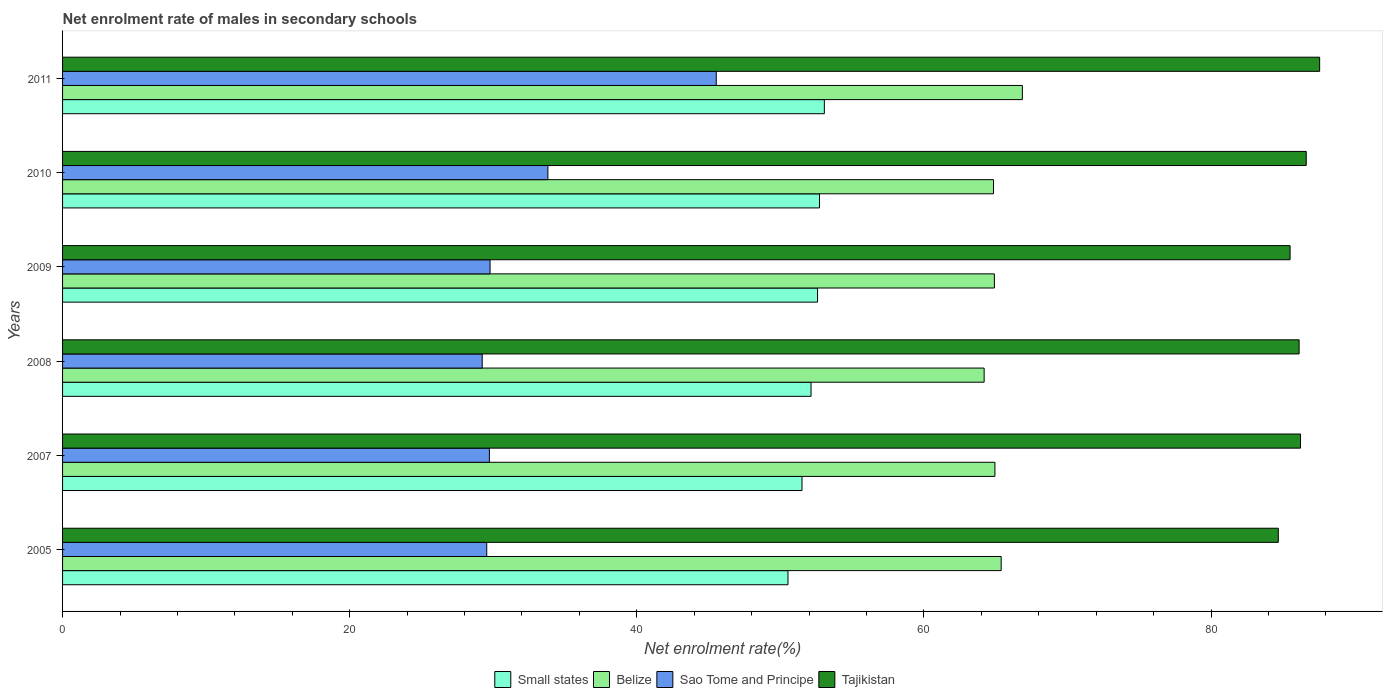How many different coloured bars are there?
Give a very brief answer. 4. How many groups of bars are there?
Your answer should be very brief. 6. Are the number of bars per tick equal to the number of legend labels?
Your response must be concise. Yes. How many bars are there on the 5th tick from the bottom?
Provide a succinct answer. 4. What is the net enrolment rate of males in secondary schools in Tajikistan in 2010?
Your answer should be compact. 86.63. Across all years, what is the maximum net enrolment rate of males in secondary schools in Sao Tome and Principe?
Give a very brief answer. 45.53. Across all years, what is the minimum net enrolment rate of males in secondary schools in Small states?
Give a very brief answer. 50.53. What is the total net enrolment rate of males in secondary schools in Sao Tome and Principe in the graph?
Provide a succinct answer. 197.62. What is the difference between the net enrolment rate of males in secondary schools in Sao Tome and Principe in 2008 and that in 2011?
Your response must be concise. -16.3. What is the difference between the net enrolment rate of males in secondary schools in Sao Tome and Principe in 2010 and the net enrolment rate of males in secondary schools in Belize in 2011?
Offer a very short reply. -33.05. What is the average net enrolment rate of males in secondary schools in Small states per year?
Make the answer very short. 52.09. In the year 2011, what is the difference between the net enrolment rate of males in secondary schools in Sao Tome and Principe and net enrolment rate of males in secondary schools in Tajikistan?
Keep it short and to the point. -42.03. What is the ratio of the net enrolment rate of males in secondary schools in Small states in 2010 to that in 2011?
Your answer should be compact. 0.99. Is the net enrolment rate of males in secondary schools in Tajikistan in 2007 less than that in 2011?
Make the answer very short. Yes. What is the difference between the highest and the second highest net enrolment rate of males in secondary schools in Small states?
Provide a succinct answer. 0.34. What is the difference between the highest and the lowest net enrolment rate of males in secondary schools in Small states?
Provide a succinct answer. 2.53. In how many years, is the net enrolment rate of males in secondary schools in Tajikistan greater than the average net enrolment rate of males in secondary schools in Tajikistan taken over all years?
Give a very brief answer. 4. Is the sum of the net enrolment rate of males in secondary schools in Sao Tome and Principe in 2008 and 2010 greater than the maximum net enrolment rate of males in secondary schools in Tajikistan across all years?
Make the answer very short. No. What does the 3rd bar from the top in 2005 represents?
Keep it short and to the point. Belize. What does the 2nd bar from the bottom in 2005 represents?
Provide a short and direct response. Belize. Are all the bars in the graph horizontal?
Offer a very short reply. Yes. How many years are there in the graph?
Offer a very short reply. 6. What is the difference between two consecutive major ticks on the X-axis?
Your answer should be very brief. 20. Does the graph contain grids?
Provide a short and direct response. No. Where does the legend appear in the graph?
Keep it short and to the point. Bottom center. What is the title of the graph?
Provide a succinct answer. Net enrolment rate of males in secondary schools. What is the label or title of the X-axis?
Your response must be concise. Net enrolment rate(%). What is the label or title of the Y-axis?
Your response must be concise. Years. What is the Net enrolment rate(%) of Small states in 2005?
Offer a terse response. 50.53. What is the Net enrolment rate(%) in Belize in 2005?
Give a very brief answer. 65.38. What is the Net enrolment rate(%) of Sao Tome and Principe in 2005?
Give a very brief answer. 29.54. What is the Net enrolment rate(%) in Tajikistan in 2005?
Keep it short and to the point. 84.68. What is the Net enrolment rate(%) in Small states in 2007?
Provide a short and direct response. 51.5. What is the Net enrolment rate(%) of Belize in 2007?
Ensure brevity in your answer.  64.94. What is the Net enrolment rate(%) of Sao Tome and Principe in 2007?
Your answer should be very brief. 29.73. What is the Net enrolment rate(%) in Tajikistan in 2007?
Your answer should be compact. 86.23. What is the Net enrolment rate(%) of Small states in 2008?
Provide a succinct answer. 52.13. What is the Net enrolment rate(%) of Belize in 2008?
Provide a succinct answer. 64.19. What is the Net enrolment rate(%) in Sao Tome and Principe in 2008?
Your answer should be compact. 29.23. What is the Net enrolment rate(%) in Tajikistan in 2008?
Provide a short and direct response. 86.13. What is the Net enrolment rate(%) in Small states in 2009?
Your response must be concise. 52.59. What is the Net enrolment rate(%) in Belize in 2009?
Your answer should be very brief. 64.9. What is the Net enrolment rate(%) in Sao Tome and Principe in 2009?
Offer a terse response. 29.78. What is the Net enrolment rate(%) of Tajikistan in 2009?
Offer a very short reply. 85.5. What is the Net enrolment rate(%) in Small states in 2010?
Your response must be concise. 52.72. What is the Net enrolment rate(%) of Belize in 2010?
Make the answer very short. 64.84. What is the Net enrolment rate(%) of Sao Tome and Principe in 2010?
Ensure brevity in your answer.  33.8. What is the Net enrolment rate(%) in Tajikistan in 2010?
Ensure brevity in your answer.  86.63. What is the Net enrolment rate(%) of Small states in 2011?
Ensure brevity in your answer.  53.06. What is the Net enrolment rate(%) of Belize in 2011?
Offer a terse response. 66.85. What is the Net enrolment rate(%) in Sao Tome and Principe in 2011?
Make the answer very short. 45.53. What is the Net enrolment rate(%) of Tajikistan in 2011?
Offer a terse response. 87.56. Across all years, what is the maximum Net enrolment rate(%) of Small states?
Offer a very short reply. 53.06. Across all years, what is the maximum Net enrolment rate(%) of Belize?
Your answer should be compact. 66.85. Across all years, what is the maximum Net enrolment rate(%) in Sao Tome and Principe?
Your answer should be very brief. 45.53. Across all years, what is the maximum Net enrolment rate(%) of Tajikistan?
Provide a short and direct response. 87.56. Across all years, what is the minimum Net enrolment rate(%) in Small states?
Offer a terse response. 50.53. Across all years, what is the minimum Net enrolment rate(%) in Belize?
Keep it short and to the point. 64.19. Across all years, what is the minimum Net enrolment rate(%) in Sao Tome and Principe?
Ensure brevity in your answer.  29.23. Across all years, what is the minimum Net enrolment rate(%) of Tajikistan?
Keep it short and to the point. 84.68. What is the total Net enrolment rate(%) in Small states in the graph?
Offer a terse response. 312.54. What is the total Net enrolment rate(%) of Belize in the graph?
Offer a very short reply. 391.11. What is the total Net enrolment rate(%) of Sao Tome and Principe in the graph?
Your answer should be compact. 197.62. What is the total Net enrolment rate(%) in Tajikistan in the graph?
Offer a very short reply. 516.72. What is the difference between the Net enrolment rate(%) in Small states in 2005 and that in 2007?
Your answer should be very brief. -0.98. What is the difference between the Net enrolment rate(%) in Belize in 2005 and that in 2007?
Your response must be concise. 0.44. What is the difference between the Net enrolment rate(%) in Sao Tome and Principe in 2005 and that in 2007?
Offer a very short reply. -0.18. What is the difference between the Net enrolment rate(%) in Tajikistan in 2005 and that in 2007?
Your response must be concise. -1.55. What is the difference between the Net enrolment rate(%) of Small states in 2005 and that in 2008?
Your response must be concise. -1.61. What is the difference between the Net enrolment rate(%) in Belize in 2005 and that in 2008?
Your answer should be compact. 1.19. What is the difference between the Net enrolment rate(%) of Sao Tome and Principe in 2005 and that in 2008?
Offer a terse response. 0.31. What is the difference between the Net enrolment rate(%) in Tajikistan in 2005 and that in 2008?
Provide a succinct answer. -1.45. What is the difference between the Net enrolment rate(%) of Small states in 2005 and that in 2009?
Your answer should be very brief. -2.06. What is the difference between the Net enrolment rate(%) in Belize in 2005 and that in 2009?
Offer a terse response. 0.47. What is the difference between the Net enrolment rate(%) in Sao Tome and Principe in 2005 and that in 2009?
Give a very brief answer. -0.23. What is the difference between the Net enrolment rate(%) in Tajikistan in 2005 and that in 2009?
Provide a short and direct response. -0.82. What is the difference between the Net enrolment rate(%) in Small states in 2005 and that in 2010?
Your answer should be compact. -2.2. What is the difference between the Net enrolment rate(%) of Belize in 2005 and that in 2010?
Ensure brevity in your answer.  0.54. What is the difference between the Net enrolment rate(%) in Sao Tome and Principe in 2005 and that in 2010?
Provide a short and direct response. -4.26. What is the difference between the Net enrolment rate(%) in Tajikistan in 2005 and that in 2010?
Your response must be concise. -1.95. What is the difference between the Net enrolment rate(%) in Small states in 2005 and that in 2011?
Keep it short and to the point. -2.53. What is the difference between the Net enrolment rate(%) of Belize in 2005 and that in 2011?
Ensure brevity in your answer.  -1.47. What is the difference between the Net enrolment rate(%) in Sao Tome and Principe in 2005 and that in 2011?
Provide a short and direct response. -15.99. What is the difference between the Net enrolment rate(%) of Tajikistan in 2005 and that in 2011?
Ensure brevity in your answer.  -2.88. What is the difference between the Net enrolment rate(%) of Small states in 2007 and that in 2008?
Your answer should be very brief. -0.63. What is the difference between the Net enrolment rate(%) in Belize in 2007 and that in 2008?
Offer a terse response. 0.75. What is the difference between the Net enrolment rate(%) of Sao Tome and Principe in 2007 and that in 2008?
Ensure brevity in your answer.  0.5. What is the difference between the Net enrolment rate(%) in Tajikistan in 2007 and that in 2008?
Provide a succinct answer. 0.1. What is the difference between the Net enrolment rate(%) of Small states in 2007 and that in 2009?
Provide a succinct answer. -1.08. What is the difference between the Net enrolment rate(%) of Belize in 2007 and that in 2009?
Your answer should be very brief. 0.04. What is the difference between the Net enrolment rate(%) of Sao Tome and Principe in 2007 and that in 2009?
Offer a terse response. -0.05. What is the difference between the Net enrolment rate(%) in Tajikistan in 2007 and that in 2009?
Give a very brief answer. 0.73. What is the difference between the Net enrolment rate(%) in Small states in 2007 and that in 2010?
Your answer should be very brief. -1.22. What is the difference between the Net enrolment rate(%) in Belize in 2007 and that in 2010?
Ensure brevity in your answer.  0.1. What is the difference between the Net enrolment rate(%) of Sao Tome and Principe in 2007 and that in 2010?
Your answer should be very brief. -4.08. What is the difference between the Net enrolment rate(%) of Tajikistan in 2007 and that in 2010?
Your answer should be compact. -0.4. What is the difference between the Net enrolment rate(%) of Small states in 2007 and that in 2011?
Provide a succinct answer. -1.56. What is the difference between the Net enrolment rate(%) of Belize in 2007 and that in 2011?
Your response must be concise. -1.91. What is the difference between the Net enrolment rate(%) of Sao Tome and Principe in 2007 and that in 2011?
Give a very brief answer. -15.8. What is the difference between the Net enrolment rate(%) in Tajikistan in 2007 and that in 2011?
Your answer should be compact. -1.33. What is the difference between the Net enrolment rate(%) in Small states in 2008 and that in 2009?
Make the answer very short. -0.45. What is the difference between the Net enrolment rate(%) in Belize in 2008 and that in 2009?
Give a very brief answer. -0.71. What is the difference between the Net enrolment rate(%) in Sao Tome and Principe in 2008 and that in 2009?
Provide a short and direct response. -0.55. What is the difference between the Net enrolment rate(%) of Tajikistan in 2008 and that in 2009?
Keep it short and to the point. 0.63. What is the difference between the Net enrolment rate(%) of Small states in 2008 and that in 2010?
Offer a very short reply. -0.59. What is the difference between the Net enrolment rate(%) of Belize in 2008 and that in 2010?
Your response must be concise. -0.65. What is the difference between the Net enrolment rate(%) of Sao Tome and Principe in 2008 and that in 2010?
Give a very brief answer. -4.58. What is the difference between the Net enrolment rate(%) of Tajikistan in 2008 and that in 2010?
Your answer should be very brief. -0.49. What is the difference between the Net enrolment rate(%) of Small states in 2008 and that in 2011?
Ensure brevity in your answer.  -0.93. What is the difference between the Net enrolment rate(%) of Belize in 2008 and that in 2011?
Ensure brevity in your answer.  -2.66. What is the difference between the Net enrolment rate(%) in Sao Tome and Principe in 2008 and that in 2011?
Provide a succinct answer. -16.3. What is the difference between the Net enrolment rate(%) in Tajikistan in 2008 and that in 2011?
Make the answer very short. -1.43. What is the difference between the Net enrolment rate(%) in Small states in 2009 and that in 2010?
Your answer should be very brief. -0.14. What is the difference between the Net enrolment rate(%) in Belize in 2009 and that in 2010?
Your answer should be compact. 0.06. What is the difference between the Net enrolment rate(%) of Sao Tome and Principe in 2009 and that in 2010?
Provide a short and direct response. -4.03. What is the difference between the Net enrolment rate(%) in Tajikistan in 2009 and that in 2010?
Keep it short and to the point. -1.12. What is the difference between the Net enrolment rate(%) in Small states in 2009 and that in 2011?
Keep it short and to the point. -0.47. What is the difference between the Net enrolment rate(%) of Belize in 2009 and that in 2011?
Offer a terse response. -1.95. What is the difference between the Net enrolment rate(%) of Sao Tome and Principe in 2009 and that in 2011?
Provide a short and direct response. -15.76. What is the difference between the Net enrolment rate(%) in Tajikistan in 2009 and that in 2011?
Your response must be concise. -2.06. What is the difference between the Net enrolment rate(%) in Small states in 2010 and that in 2011?
Make the answer very short. -0.34. What is the difference between the Net enrolment rate(%) in Belize in 2010 and that in 2011?
Ensure brevity in your answer.  -2.01. What is the difference between the Net enrolment rate(%) of Sao Tome and Principe in 2010 and that in 2011?
Keep it short and to the point. -11.73. What is the difference between the Net enrolment rate(%) in Tajikistan in 2010 and that in 2011?
Your answer should be very brief. -0.93. What is the difference between the Net enrolment rate(%) in Small states in 2005 and the Net enrolment rate(%) in Belize in 2007?
Make the answer very short. -14.41. What is the difference between the Net enrolment rate(%) of Small states in 2005 and the Net enrolment rate(%) of Sao Tome and Principe in 2007?
Keep it short and to the point. 20.8. What is the difference between the Net enrolment rate(%) of Small states in 2005 and the Net enrolment rate(%) of Tajikistan in 2007?
Keep it short and to the point. -35.7. What is the difference between the Net enrolment rate(%) of Belize in 2005 and the Net enrolment rate(%) of Sao Tome and Principe in 2007?
Your response must be concise. 35.65. What is the difference between the Net enrolment rate(%) in Belize in 2005 and the Net enrolment rate(%) in Tajikistan in 2007?
Keep it short and to the point. -20.85. What is the difference between the Net enrolment rate(%) in Sao Tome and Principe in 2005 and the Net enrolment rate(%) in Tajikistan in 2007?
Your answer should be very brief. -56.68. What is the difference between the Net enrolment rate(%) of Small states in 2005 and the Net enrolment rate(%) of Belize in 2008?
Ensure brevity in your answer.  -13.66. What is the difference between the Net enrolment rate(%) in Small states in 2005 and the Net enrolment rate(%) in Sao Tome and Principe in 2008?
Offer a very short reply. 21.3. What is the difference between the Net enrolment rate(%) in Small states in 2005 and the Net enrolment rate(%) in Tajikistan in 2008?
Your answer should be very brief. -35.6. What is the difference between the Net enrolment rate(%) of Belize in 2005 and the Net enrolment rate(%) of Sao Tome and Principe in 2008?
Provide a short and direct response. 36.15. What is the difference between the Net enrolment rate(%) in Belize in 2005 and the Net enrolment rate(%) in Tajikistan in 2008?
Keep it short and to the point. -20.75. What is the difference between the Net enrolment rate(%) in Sao Tome and Principe in 2005 and the Net enrolment rate(%) in Tajikistan in 2008?
Offer a very short reply. -56.59. What is the difference between the Net enrolment rate(%) in Small states in 2005 and the Net enrolment rate(%) in Belize in 2009?
Offer a very short reply. -14.38. What is the difference between the Net enrolment rate(%) of Small states in 2005 and the Net enrolment rate(%) of Sao Tome and Principe in 2009?
Offer a terse response. 20.75. What is the difference between the Net enrolment rate(%) in Small states in 2005 and the Net enrolment rate(%) in Tajikistan in 2009?
Your response must be concise. -34.97. What is the difference between the Net enrolment rate(%) of Belize in 2005 and the Net enrolment rate(%) of Sao Tome and Principe in 2009?
Your answer should be very brief. 35.6. What is the difference between the Net enrolment rate(%) in Belize in 2005 and the Net enrolment rate(%) in Tajikistan in 2009?
Provide a short and direct response. -20.12. What is the difference between the Net enrolment rate(%) of Sao Tome and Principe in 2005 and the Net enrolment rate(%) of Tajikistan in 2009?
Offer a very short reply. -55.96. What is the difference between the Net enrolment rate(%) of Small states in 2005 and the Net enrolment rate(%) of Belize in 2010?
Make the answer very short. -14.31. What is the difference between the Net enrolment rate(%) in Small states in 2005 and the Net enrolment rate(%) in Sao Tome and Principe in 2010?
Give a very brief answer. 16.72. What is the difference between the Net enrolment rate(%) of Small states in 2005 and the Net enrolment rate(%) of Tajikistan in 2010?
Keep it short and to the point. -36.1. What is the difference between the Net enrolment rate(%) of Belize in 2005 and the Net enrolment rate(%) of Sao Tome and Principe in 2010?
Give a very brief answer. 31.57. What is the difference between the Net enrolment rate(%) of Belize in 2005 and the Net enrolment rate(%) of Tajikistan in 2010?
Ensure brevity in your answer.  -21.25. What is the difference between the Net enrolment rate(%) of Sao Tome and Principe in 2005 and the Net enrolment rate(%) of Tajikistan in 2010?
Keep it short and to the point. -57.08. What is the difference between the Net enrolment rate(%) of Small states in 2005 and the Net enrolment rate(%) of Belize in 2011?
Offer a terse response. -16.33. What is the difference between the Net enrolment rate(%) in Small states in 2005 and the Net enrolment rate(%) in Sao Tome and Principe in 2011?
Provide a short and direct response. 5. What is the difference between the Net enrolment rate(%) in Small states in 2005 and the Net enrolment rate(%) in Tajikistan in 2011?
Ensure brevity in your answer.  -37.03. What is the difference between the Net enrolment rate(%) of Belize in 2005 and the Net enrolment rate(%) of Sao Tome and Principe in 2011?
Ensure brevity in your answer.  19.85. What is the difference between the Net enrolment rate(%) in Belize in 2005 and the Net enrolment rate(%) in Tajikistan in 2011?
Offer a terse response. -22.18. What is the difference between the Net enrolment rate(%) in Sao Tome and Principe in 2005 and the Net enrolment rate(%) in Tajikistan in 2011?
Your response must be concise. -58.01. What is the difference between the Net enrolment rate(%) of Small states in 2007 and the Net enrolment rate(%) of Belize in 2008?
Your answer should be very brief. -12.69. What is the difference between the Net enrolment rate(%) in Small states in 2007 and the Net enrolment rate(%) in Sao Tome and Principe in 2008?
Make the answer very short. 22.27. What is the difference between the Net enrolment rate(%) of Small states in 2007 and the Net enrolment rate(%) of Tajikistan in 2008?
Provide a short and direct response. -34.63. What is the difference between the Net enrolment rate(%) in Belize in 2007 and the Net enrolment rate(%) in Sao Tome and Principe in 2008?
Give a very brief answer. 35.71. What is the difference between the Net enrolment rate(%) in Belize in 2007 and the Net enrolment rate(%) in Tajikistan in 2008?
Provide a succinct answer. -21.19. What is the difference between the Net enrolment rate(%) of Sao Tome and Principe in 2007 and the Net enrolment rate(%) of Tajikistan in 2008?
Offer a very short reply. -56.4. What is the difference between the Net enrolment rate(%) in Small states in 2007 and the Net enrolment rate(%) in Belize in 2009?
Give a very brief answer. -13.4. What is the difference between the Net enrolment rate(%) of Small states in 2007 and the Net enrolment rate(%) of Sao Tome and Principe in 2009?
Your answer should be compact. 21.73. What is the difference between the Net enrolment rate(%) in Small states in 2007 and the Net enrolment rate(%) in Tajikistan in 2009?
Your answer should be compact. -34. What is the difference between the Net enrolment rate(%) in Belize in 2007 and the Net enrolment rate(%) in Sao Tome and Principe in 2009?
Offer a terse response. 35.17. What is the difference between the Net enrolment rate(%) in Belize in 2007 and the Net enrolment rate(%) in Tajikistan in 2009?
Ensure brevity in your answer.  -20.56. What is the difference between the Net enrolment rate(%) in Sao Tome and Principe in 2007 and the Net enrolment rate(%) in Tajikistan in 2009?
Ensure brevity in your answer.  -55.77. What is the difference between the Net enrolment rate(%) in Small states in 2007 and the Net enrolment rate(%) in Belize in 2010?
Ensure brevity in your answer.  -13.34. What is the difference between the Net enrolment rate(%) of Small states in 2007 and the Net enrolment rate(%) of Sao Tome and Principe in 2010?
Provide a short and direct response. 17.7. What is the difference between the Net enrolment rate(%) of Small states in 2007 and the Net enrolment rate(%) of Tajikistan in 2010?
Your answer should be very brief. -35.12. What is the difference between the Net enrolment rate(%) in Belize in 2007 and the Net enrolment rate(%) in Sao Tome and Principe in 2010?
Your answer should be compact. 31.14. What is the difference between the Net enrolment rate(%) of Belize in 2007 and the Net enrolment rate(%) of Tajikistan in 2010?
Your answer should be very brief. -21.68. What is the difference between the Net enrolment rate(%) of Sao Tome and Principe in 2007 and the Net enrolment rate(%) of Tajikistan in 2010?
Offer a very short reply. -56.9. What is the difference between the Net enrolment rate(%) in Small states in 2007 and the Net enrolment rate(%) in Belize in 2011?
Provide a succinct answer. -15.35. What is the difference between the Net enrolment rate(%) of Small states in 2007 and the Net enrolment rate(%) of Sao Tome and Principe in 2011?
Offer a very short reply. 5.97. What is the difference between the Net enrolment rate(%) of Small states in 2007 and the Net enrolment rate(%) of Tajikistan in 2011?
Offer a very short reply. -36.06. What is the difference between the Net enrolment rate(%) of Belize in 2007 and the Net enrolment rate(%) of Sao Tome and Principe in 2011?
Make the answer very short. 19.41. What is the difference between the Net enrolment rate(%) in Belize in 2007 and the Net enrolment rate(%) in Tajikistan in 2011?
Keep it short and to the point. -22.62. What is the difference between the Net enrolment rate(%) in Sao Tome and Principe in 2007 and the Net enrolment rate(%) in Tajikistan in 2011?
Keep it short and to the point. -57.83. What is the difference between the Net enrolment rate(%) in Small states in 2008 and the Net enrolment rate(%) in Belize in 2009?
Provide a short and direct response. -12.77. What is the difference between the Net enrolment rate(%) of Small states in 2008 and the Net enrolment rate(%) of Sao Tome and Principe in 2009?
Your response must be concise. 22.36. What is the difference between the Net enrolment rate(%) of Small states in 2008 and the Net enrolment rate(%) of Tajikistan in 2009?
Give a very brief answer. -33.37. What is the difference between the Net enrolment rate(%) of Belize in 2008 and the Net enrolment rate(%) of Sao Tome and Principe in 2009?
Provide a short and direct response. 34.41. What is the difference between the Net enrolment rate(%) in Belize in 2008 and the Net enrolment rate(%) in Tajikistan in 2009?
Your response must be concise. -21.31. What is the difference between the Net enrolment rate(%) of Sao Tome and Principe in 2008 and the Net enrolment rate(%) of Tajikistan in 2009?
Make the answer very short. -56.27. What is the difference between the Net enrolment rate(%) in Small states in 2008 and the Net enrolment rate(%) in Belize in 2010?
Your response must be concise. -12.71. What is the difference between the Net enrolment rate(%) of Small states in 2008 and the Net enrolment rate(%) of Sao Tome and Principe in 2010?
Provide a succinct answer. 18.33. What is the difference between the Net enrolment rate(%) of Small states in 2008 and the Net enrolment rate(%) of Tajikistan in 2010?
Offer a terse response. -34.49. What is the difference between the Net enrolment rate(%) in Belize in 2008 and the Net enrolment rate(%) in Sao Tome and Principe in 2010?
Your response must be concise. 30.39. What is the difference between the Net enrolment rate(%) in Belize in 2008 and the Net enrolment rate(%) in Tajikistan in 2010?
Your response must be concise. -22.43. What is the difference between the Net enrolment rate(%) of Sao Tome and Principe in 2008 and the Net enrolment rate(%) of Tajikistan in 2010?
Keep it short and to the point. -57.4. What is the difference between the Net enrolment rate(%) in Small states in 2008 and the Net enrolment rate(%) in Belize in 2011?
Your answer should be compact. -14.72. What is the difference between the Net enrolment rate(%) in Small states in 2008 and the Net enrolment rate(%) in Sao Tome and Principe in 2011?
Your answer should be very brief. 6.6. What is the difference between the Net enrolment rate(%) in Small states in 2008 and the Net enrolment rate(%) in Tajikistan in 2011?
Provide a succinct answer. -35.43. What is the difference between the Net enrolment rate(%) of Belize in 2008 and the Net enrolment rate(%) of Sao Tome and Principe in 2011?
Give a very brief answer. 18.66. What is the difference between the Net enrolment rate(%) in Belize in 2008 and the Net enrolment rate(%) in Tajikistan in 2011?
Keep it short and to the point. -23.37. What is the difference between the Net enrolment rate(%) in Sao Tome and Principe in 2008 and the Net enrolment rate(%) in Tajikistan in 2011?
Offer a very short reply. -58.33. What is the difference between the Net enrolment rate(%) of Small states in 2009 and the Net enrolment rate(%) of Belize in 2010?
Offer a very short reply. -12.26. What is the difference between the Net enrolment rate(%) of Small states in 2009 and the Net enrolment rate(%) of Sao Tome and Principe in 2010?
Your answer should be very brief. 18.78. What is the difference between the Net enrolment rate(%) of Small states in 2009 and the Net enrolment rate(%) of Tajikistan in 2010?
Give a very brief answer. -34.04. What is the difference between the Net enrolment rate(%) of Belize in 2009 and the Net enrolment rate(%) of Sao Tome and Principe in 2010?
Provide a succinct answer. 31.1. What is the difference between the Net enrolment rate(%) in Belize in 2009 and the Net enrolment rate(%) in Tajikistan in 2010?
Offer a very short reply. -21.72. What is the difference between the Net enrolment rate(%) of Sao Tome and Principe in 2009 and the Net enrolment rate(%) of Tajikistan in 2010?
Provide a succinct answer. -56.85. What is the difference between the Net enrolment rate(%) of Small states in 2009 and the Net enrolment rate(%) of Belize in 2011?
Provide a succinct answer. -14.27. What is the difference between the Net enrolment rate(%) of Small states in 2009 and the Net enrolment rate(%) of Sao Tome and Principe in 2011?
Keep it short and to the point. 7.05. What is the difference between the Net enrolment rate(%) in Small states in 2009 and the Net enrolment rate(%) in Tajikistan in 2011?
Provide a succinct answer. -34.97. What is the difference between the Net enrolment rate(%) in Belize in 2009 and the Net enrolment rate(%) in Sao Tome and Principe in 2011?
Keep it short and to the point. 19.37. What is the difference between the Net enrolment rate(%) in Belize in 2009 and the Net enrolment rate(%) in Tajikistan in 2011?
Your response must be concise. -22.65. What is the difference between the Net enrolment rate(%) in Sao Tome and Principe in 2009 and the Net enrolment rate(%) in Tajikistan in 2011?
Make the answer very short. -57.78. What is the difference between the Net enrolment rate(%) of Small states in 2010 and the Net enrolment rate(%) of Belize in 2011?
Ensure brevity in your answer.  -14.13. What is the difference between the Net enrolment rate(%) in Small states in 2010 and the Net enrolment rate(%) in Sao Tome and Principe in 2011?
Your answer should be compact. 7.19. What is the difference between the Net enrolment rate(%) of Small states in 2010 and the Net enrolment rate(%) of Tajikistan in 2011?
Provide a short and direct response. -34.84. What is the difference between the Net enrolment rate(%) of Belize in 2010 and the Net enrolment rate(%) of Sao Tome and Principe in 2011?
Your answer should be very brief. 19.31. What is the difference between the Net enrolment rate(%) in Belize in 2010 and the Net enrolment rate(%) in Tajikistan in 2011?
Your response must be concise. -22.72. What is the difference between the Net enrolment rate(%) of Sao Tome and Principe in 2010 and the Net enrolment rate(%) of Tajikistan in 2011?
Provide a succinct answer. -53.75. What is the average Net enrolment rate(%) in Small states per year?
Your response must be concise. 52.09. What is the average Net enrolment rate(%) in Belize per year?
Offer a very short reply. 65.19. What is the average Net enrolment rate(%) in Sao Tome and Principe per year?
Offer a terse response. 32.94. What is the average Net enrolment rate(%) of Tajikistan per year?
Ensure brevity in your answer.  86.12. In the year 2005, what is the difference between the Net enrolment rate(%) in Small states and Net enrolment rate(%) in Belize?
Provide a short and direct response. -14.85. In the year 2005, what is the difference between the Net enrolment rate(%) in Small states and Net enrolment rate(%) in Sao Tome and Principe?
Offer a very short reply. 20.98. In the year 2005, what is the difference between the Net enrolment rate(%) of Small states and Net enrolment rate(%) of Tajikistan?
Give a very brief answer. -34.15. In the year 2005, what is the difference between the Net enrolment rate(%) in Belize and Net enrolment rate(%) in Sao Tome and Principe?
Keep it short and to the point. 35.83. In the year 2005, what is the difference between the Net enrolment rate(%) in Belize and Net enrolment rate(%) in Tajikistan?
Ensure brevity in your answer.  -19.3. In the year 2005, what is the difference between the Net enrolment rate(%) in Sao Tome and Principe and Net enrolment rate(%) in Tajikistan?
Your answer should be compact. -55.14. In the year 2007, what is the difference between the Net enrolment rate(%) in Small states and Net enrolment rate(%) in Belize?
Your answer should be compact. -13.44. In the year 2007, what is the difference between the Net enrolment rate(%) in Small states and Net enrolment rate(%) in Sao Tome and Principe?
Your response must be concise. 21.77. In the year 2007, what is the difference between the Net enrolment rate(%) of Small states and Net enrolment rate(%) of Tajikistan?
Keep it short and to the point. -34.72. In the year 2007, what is the difference between the Net enrolment rate(%) in Belize and Net enrolment rate(%) in Sao Tome and Principe?
Give a very brief answer. 35.21. In the year 2007, what is the difference between the Net enrolment rate(%) in Belize and Net enrolment rate(%) in Tajikistan?
Provide a short and direct response. -21.29. In the year 2007, what is the difference between the Net enrolment rate(%) of Sao Tome and Principe and Net enrolment rate(%) of Tajikistan?
Keep it short and to the point. -56.5. In the year 2008, what is the difference between the Net enrolment rate(%) of Small states and Net enrolment rate(%) of Belize?
Your response must be concise. -12.06. In the year 2008, what is the difference between the Net enrolment rate(%) in Small states and Net enrolment rate(%) in Sao Tome and Principe?
Make the answer very short. 22.9. In the year 2008, what is the difference between the Net enrolment rate(%) of Small states and Net enrolment rate(%) of Tajikistan?
Your answer should be very brief. -34. In the year 2008, what is the difference between the Net enrolment rate(%) of Belize and Net enrolment rate(%) of Sao Tome and Principe?
Provide a succinct answer. 34.96. In the year 2008, what is the difference between the Net enrolment rate(%) of Belize and Net enrolment rate(%) of Tajikistan?
Provide a short and direct response. -21.94. In the year 2008, what is the difference between the Net enrolment rate(%) in Sao Tome and Principe and Net enrolment rate(%) in Tajikistan?
Give a very brief answer. -56.9. In the year 2009, what is the difference between the Net enrolment rate(%) of Small states and Net enrolment rate(%) of Belize?
Your answer should be very brief. -12.32. In the year 2009, what is the difference between the Net enrolment rate(%) of Small states and Net enrolment rate(%) of Sao Tome and Principe?
Your answer should be compact. 22.81. In the year 2009, what is the difference between the Net enrolment rate(%) in Small states and Net enrolment rate(%) in Tajikistan?
Your answer should be very brief. -32.92. In the year 2009, what is the difference between the Net enrolment rate(%) in Belize and Net enrolment rate(%) in Sao Tome and Principe?
Provide a succinct answer. 35.13. In the year 2009, what is the difference between the Net enrolment rate(%) of Belize and Net enrolment rate(%) of Tajikistan?
Give a very brief answer. -20.6. In the year 2009, what is the difference between the Net enrolment rate(%) of Sao Tome and Principe and Net enrolment rate(%) of Tajikistan?
Offer a very short reply. -55.72. In the year 2010, what is the difference between the Net enrolment rate(%) of Small states and Net enrolment rate(%) of Belize?
Provide a succinct answer. -12.12. In the year 2010, what is the difference between the Net enrolment rate(%) of Small states and Net enrolment rate(%) of Sao Tome and Principe?
Keep it short and to the point. 18.92. In the year 2010, what is the difference between the Net enrolment rate(%) in Small states and Net enrolment rate(%) in Tajikistan?
Your answer should be compact. -33.9. In the year 2010, what is the difference between the Net enrolment rate(%) of Belize and Net enrolment rate(%) of Sao Tome and Principe?
Provide a short and direct response. 31.04. In the year 2010, what is the difference between the Net enrolment rate(%) of Belize and Net enrolment rate(%) of Tajikistan?
Your response must be concise. -21.78. In the year 2010, what is the difference between the Net enrolment rate(%) in Sao Tome and Principe and Net enrolment rate(%) in Tajikistan?
Provide a short and direct response. -52.82. In the year 2011, what is the difference between the Net enrolment rate(%) in Small states and Net enrolment rate(%) in Belize?
Make the answer very short. -13.79. In the year 2011, what is the difference between the Net enrolment rate(%) in Small states and Net enrolment rate(%) in Sao Tome and Principe?
Offer a very short reply. 7.53. In the year 2011, what is the difference between the Net enrolment rate(%) in Small states and Net enrolment rate(%) in Tajikistan?
Provide a short and direct response. -34.5. In the year 2011, what is the difference between the Net enrolment rate(%) of Belize and Net enrolment rate(%) of Sao Tome and Principe?
Make the answer very short. 21.32. In the year 2011, what is the difference between the Net enrolment rate(%) of Belize and Net enrolment rate(%) of Tajikistan?
Ensure brevity in your answer.  -20.71. In the year 2011, what is the difference between the Net enrolment rate(%) in Sao Tome and Principe and Net enrolment rate(%) in Tajikistan?
Your answer should be compact. -42.03. What is the ratio of the Net enrolment rate(%) of Small states in 2005 to that in 2007?
Offer a terse response. 0.98. What is the ratio of the Net enrolment rate(%) of Belize in 2005 to that in 2007?
Keep it short and to the point. 1.01. What is the ratio of the Net enrolment rate(%) in Tajikistan in 2005 to that in 2007?
Ensure brevity in your answer.  0.98. What is the ratio of the Net enrolment rate(%) of Small states in 2005 to that in 2008?
Your answer should be very brief. 0.97. What is the ratio of the Net enrolment rate(%) in Belize in 2005 to that in 2008?
Keep it short and to the point. 1.02. What is the ratio of the Net enrolment rate(%) of Sao Tome and Principe in 2005 to that in 2008?
Ensure brevity in your answer.  1.01. What is the ratio of the Net enrolment rate(%) in Tajikistan in 2005 to that in 2008?
Provide a succinct answer. 0.98. What is the ratio of the Net enrolment rate(%) of Small states in 2005 to that in 2009?
Offer a terse response. 0.96. What is the ratio of the Net enrolment rate(%) of Belize in 2005 to that in 2009?
Your answer should be compact. 1.01. What is the ratio of the Net enrolment rate(%) in Small states in 2005 to that in 2010?
Provide a succinct answer. 0.96. What is the ratio of the Net enrolment rate(%) of Belize in 2005 to that in 2010?
Your answer should be very brief. 1.01. What is the ratio of the Net enrolment rate(%) of Sao Tome and Principe in 2005 to that in 2010?
Provide a short and direct response. 0.87. What is the ratio of the Net enrolment rate(%) of Tajikistan in 2005 to that in 2010?
Ensure brevity in your answer.  0.98. What is the ratio of the Net enrolment rate(%) of Small states in 2005 to that in 2011?
Provide a short and direct response. 0.95. What is the ratio of the Net enrolment rate(%) of Belize in 2005 to that in 2011?
Provide a short and direct response. 0.98. What is the ratio of the Net enrolment rate(%) in Sao Tome and Principe in 2005 to that in 2011?
Ensure brevity in your answer.  0.65. What is the ratio of the Net enrolment rate(%) in Tajikistan in 2005 to that in 2011?
Provide a short and direct response. 0.97. What is the ratio of the Net enrolment rate(%) of Small states in 2007 to that in 2008?
Offer a terse response. 0.99. What is the ratio of the Net enrolment rate(%) of Belize in 2007 to that in 2008?
Give a very brief answer. 1.01. What is the ratio of the Net enrolment rate(%) in Sao Tome and Principe in 2007 to that in 2008?
Make the answer very short. 1.02. What is the ratio of the Net enrolment rate(%) of Small states in 2007 to that in 2009?
Your answer should be compact. 0.98. What is the ratio of the Net enrolment rate(%) of Belize in 2007 to that in 2009?
Give a very brief answer. 1. What is the ratio of the Net enrolment rate(%) in Sao Tome and Principe in 2007 to that in 2009?
Offer a very short reply. 1. What is the ratio of the Net enrolment rate(%) in Tajikistan in 2007 to that in 2009?
Offer a terse response. 1.01. What is the ratio of the Net enrolment rate(%) in Small states in 2007 to that in 2010?
Your response must be concise. 0.98. What is the ratio of the Net enrolment rate(%) in Belize in 2007 to that in 2010?
Offer a terse response. 1. What is the ratio of the Net enrolment rate(%) of Sao Tome and Principe in 2007 to that in 2010?
Your answer should be compact. 0.88. What is the ratio of the Net enrolment rate(%) in Tajikistan in 2007 to that in 2010?
Give a very brief answer. 1. What is the ratio of the Net enrolment rate(%) of Small states in 2007 to that in 2011?
Provide a short and direct response. 0.97. What is the ratio of the Net enrolment rate(%) in Belize in 2007 to that in 2011?
Ensure brevity in your answer.  0.97. What is the ratio of the Net enrolment rate(%) of Sao Tome and Principe in 2007 to that in 2011?
Your response must be concise. 0.65. What is the ratio of the Net enrolment rate(%) of Tajikistan in 2007 to that in 2011?
Your answer should be compact. 0.98. What is the ratio of the Net enrolment rate(%) in Small states in 2008 to that in 2009?
Provide a succinct answer. 0.99. What is the ratio of the Net enrolment rate(%) of Sao Tome and Principe in 2008 to that in 2009?
Keep it short and to the point. 0.98. What is the ratio of the Net enrolment rate(%) in Tajikistan in 2008 to that in 2009?
Make the answer very short. 1.01. What is the ratio of the Net enrolment rate(%) in Belize in 2008 to that in 2010?
Provide a short and direct response. 0.99. What is the ratio of the Net enrolment rate(%) of Sao Tome and Principe in 2008 to that in 2010?
Your answer should be very brief. 0.86. What is the ratio of the Net enrolment rate(%) in Small states in 2008 to that in 2011?
Keep it short and to the point. 0.98. What is the ratio of the Net enrolment rate(%) of Belize in 2008 to that in 2011?
Your answer should be compact. 0.96. What is the ratio of the Net enrolment rate(%) in Sao Tome and Principe in 2008 to that in 2011?
Make the answer very short. 0.64. What is the ratio of the Net enrolment rate(%) of Tajikistan in 2008 to that in 2011?
Provide a short and direct response. 0.98. What is the ratio of the Net enrolment rate(%) of Sao Tome and Principe in 2009 to that in 2010?
Your answer should be compact. 0.88. What is the ratio of the Net enrolment rate(%) in Tajikistan in 2009 to that in 2010?
Ensure brevity in your answer.  0.99. What is the ratio of the Net enrolment rate(%) in Small states in 2009 to that in 2011?
Provide a short and direct response. 0.99. What is the ratio of the Net enrolment rate(%) in Belize in 2009 to that in 2011?
Your answer should be very brief. 0.97. What is the ratio of the Net enrolment rate(%) in Sao Tome and Principe in 2009 to that in 2011?
Provide a short and direct response. 0.65. What is the ratio of the Net enrolment rate(%) of Tajikistan in 2009 to that in 2011?
Your answer should be compact. 0.98. What is the ratio of the Net enrolment rate(%) of Belize in 2010 to that in 2011?
Keep it short and to the point. 0.97. What is the ratio of the Net enrolment rate(%) in Sao Tome and Principe in 2010 to that in 2011?
Offer a very short reply. 0.74. What is the ratio of the Net enrolment rate(%) in Tajikistan in 2010 to that in 2011?
Provide a succinct answer. 0.99. What is the difference between the highest and the second highest Net enrolment rate(%) of Small states?
Your answer should be very brief. 0.34. What is the difference between the highest and the second highest Net enrolment rate(%) of Belize?
Provide a short and direct response. 1.47. What is the difference between the highest and the second highest Net enrolment rate(%) of Sao Tome and Principe?
Provide a short and direct response. 11.73. What is the difference between the highest and the second highest Net enrolment rate(%) of Tajikistan?
Offer a terse response. 0.93. What is the difference between the highest and the lowest Net enrolment rate(%) in Small states?
Give a very brief answer. 2.53. What is the difference between the highest and the lowest Net enrolment rate(%) of Belize?
Your answer should be compact. 2.66. What is the difference between the highest and the lowest Net enrolment rate(%) in Sao Tome and Principe?
Your answer should be very brief. 16.3. What is the difference between the highest and the lowest Net enrolment rate(%) of Tajikistan?
Give a very brief answer. 2.88. 